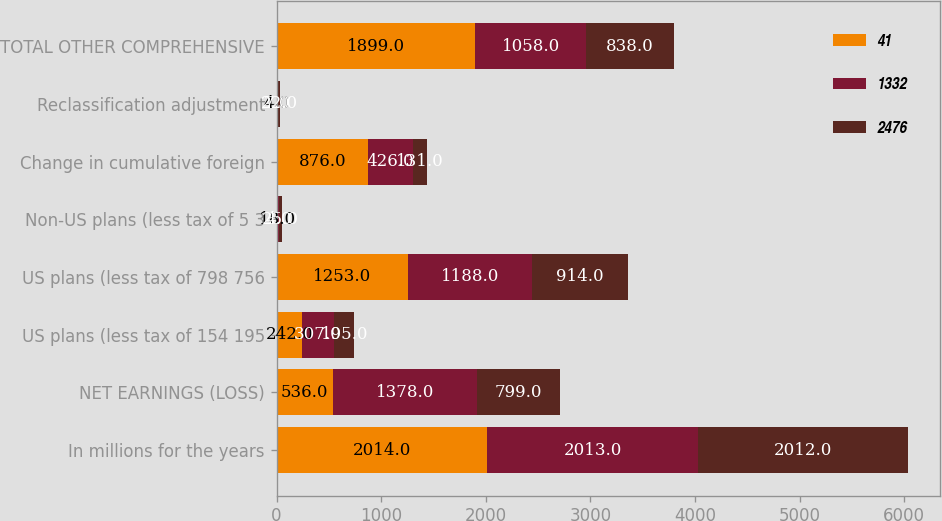<chart> <loc_0><loc_0><loc_500><loc_500><stacked_bar_chart><ecel><fcel>In millions for the years<fcel>NET EARNINGS (LOSS)<fcel>US plans (less tax of 154 195<fcel>US plans (less tax of 798 756<fcel>Non-US plans (less tax of 5 3<fcel>Change in cumulative foreign<fcel>Reclassification adjustment<fcel>TOTAL OTHER COMPREHENSIVE<nl><fcel>41<fcel>2014<fcel>536<fcel>242<fcel>1253<fcel>18<fcel>876<fcel>4<fcel>1899<nl><fcel>1332<fcel>2013<fcel>1378<fcel>307<fcel>1188<fcel>4<fcel>426<fcel>7<fcel>1058<nl><fcel>2476<fcel>2012<fcel>799<fcel>195<fcel>914<fcel>25<fcel>131<fcel>22<fcel>838<nl></chart> 